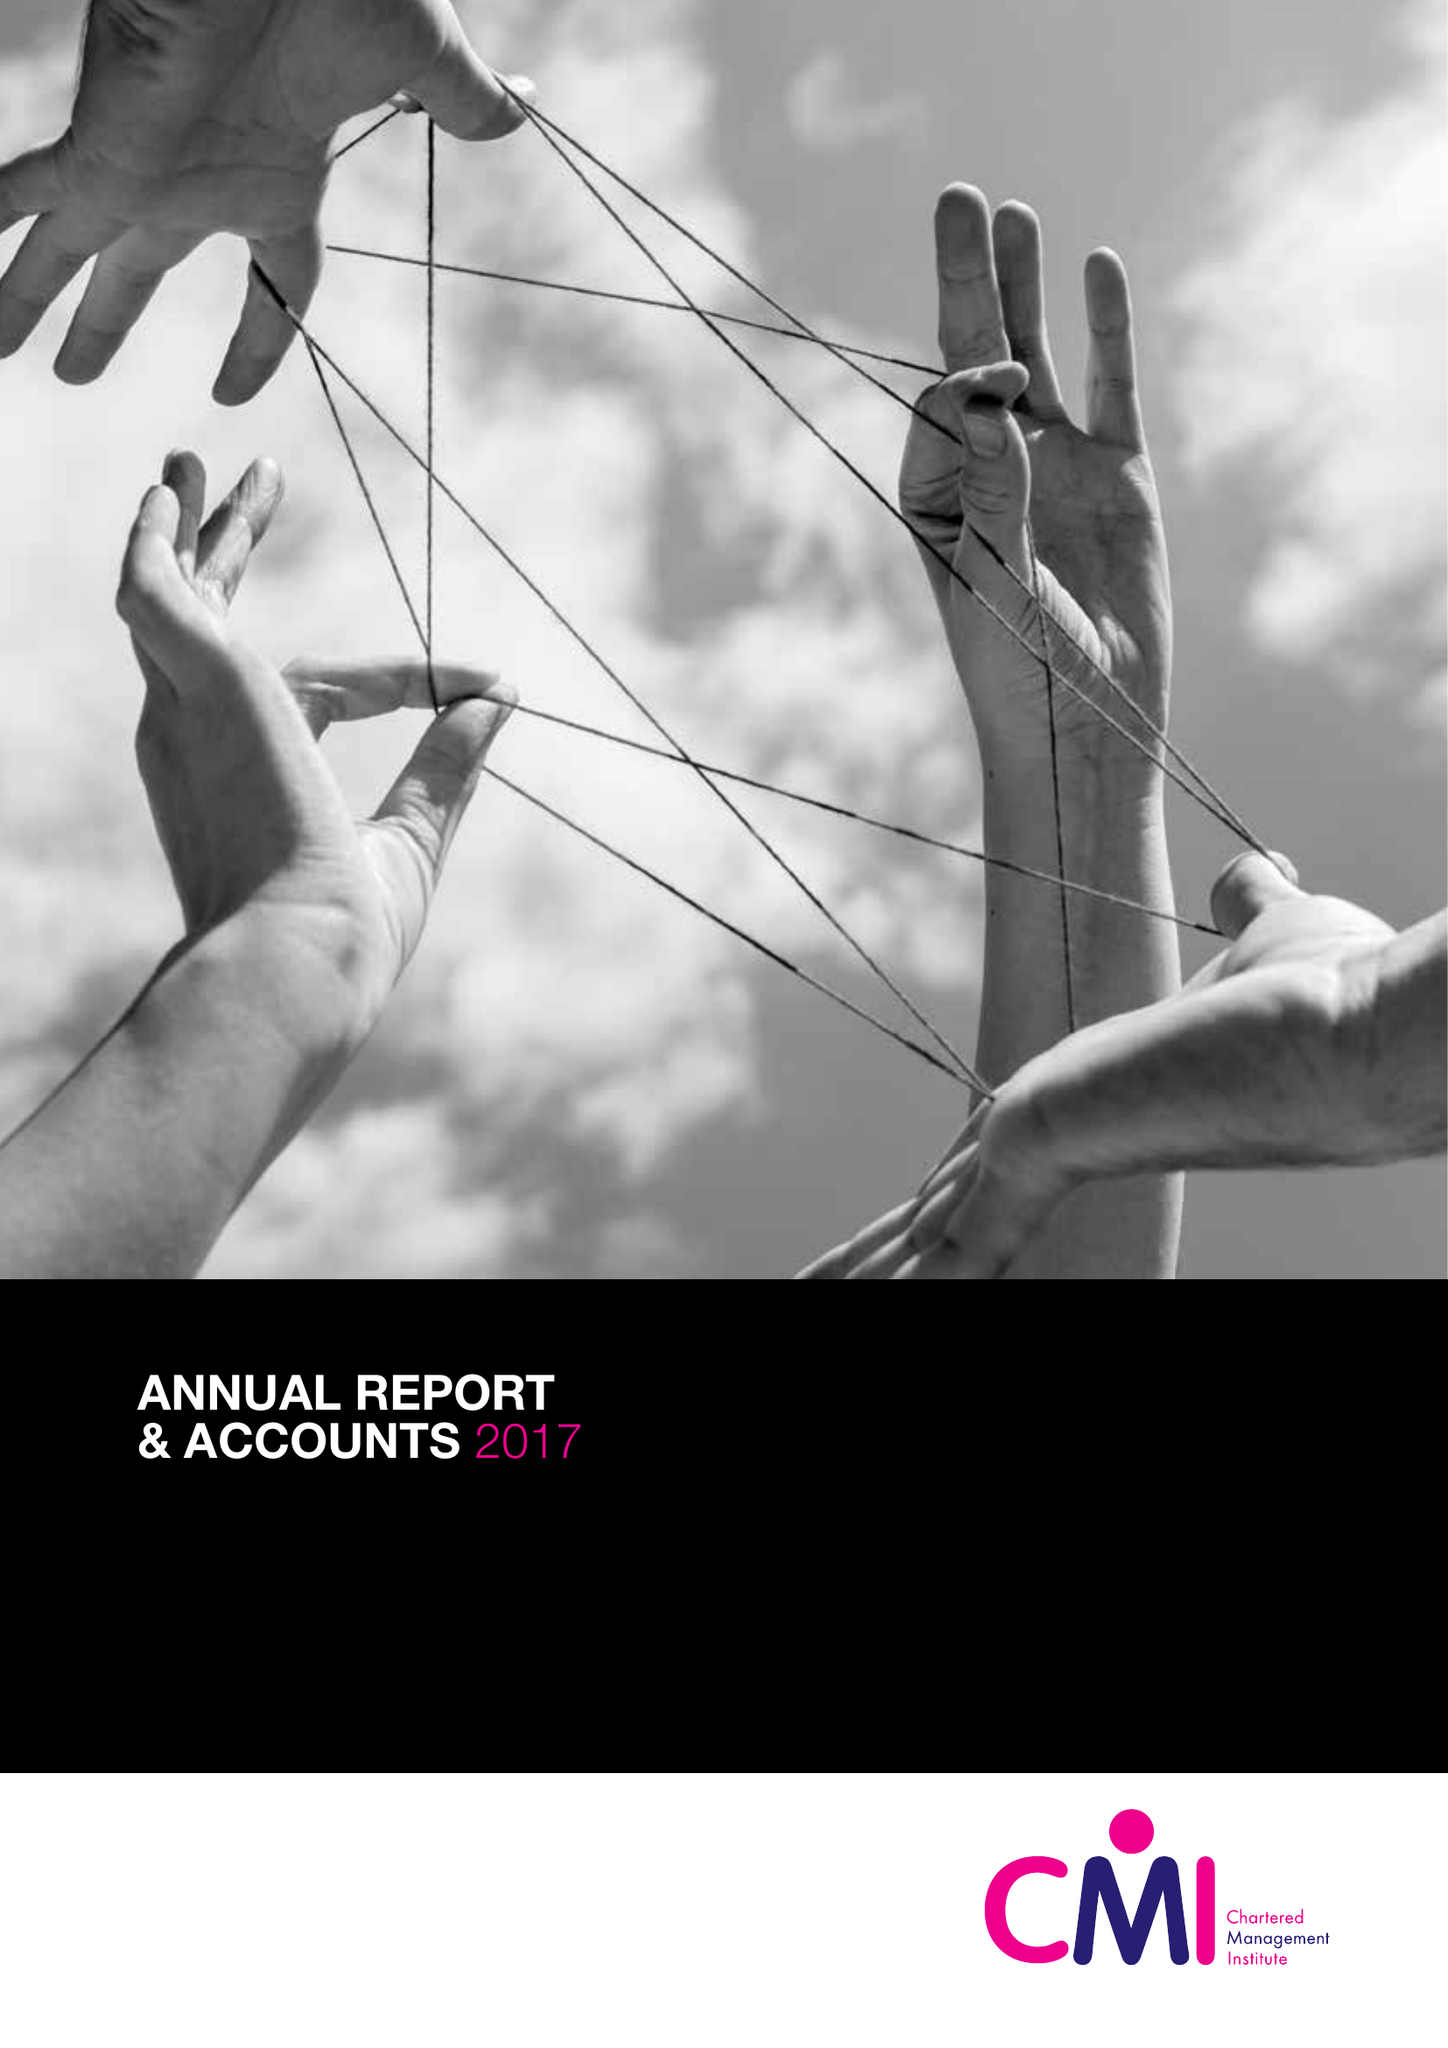What is the value for the income_annually_in_british_pounds?
Answer the question using a single word or phrase. 13253000.00 